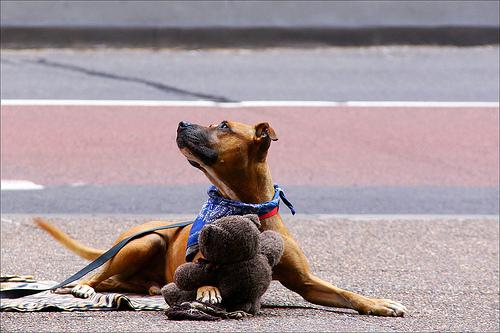Question: what is the dog wearing?
Choices:
A. A collar.
B. A hat.
C. A sweater.
D. A bandana.
Answer with the letter. Answer: D Question: who is the main focus of this picture?
Choices:
A. A cat.
B. A bird.
C. A horse.
D. A dog.
Answer with the letter. Answer: D Question: what color is the dog's collar?
Choices:
A. Blue.
B. Red.
C. White.
D. Purple.
Answer with the letter. Answer: B Question: where was this picture taken?
Choices:
A. Outside, during the daytime.
B. Inside.
C. At the beach.
D. At the zoo.
Answer with the letter. Answer: A Question: what color is the dog's bandanna?
Choices:
A. Red.
B. White.
C. Blue.
D. Green.
Answer with the letter. Answer: C 